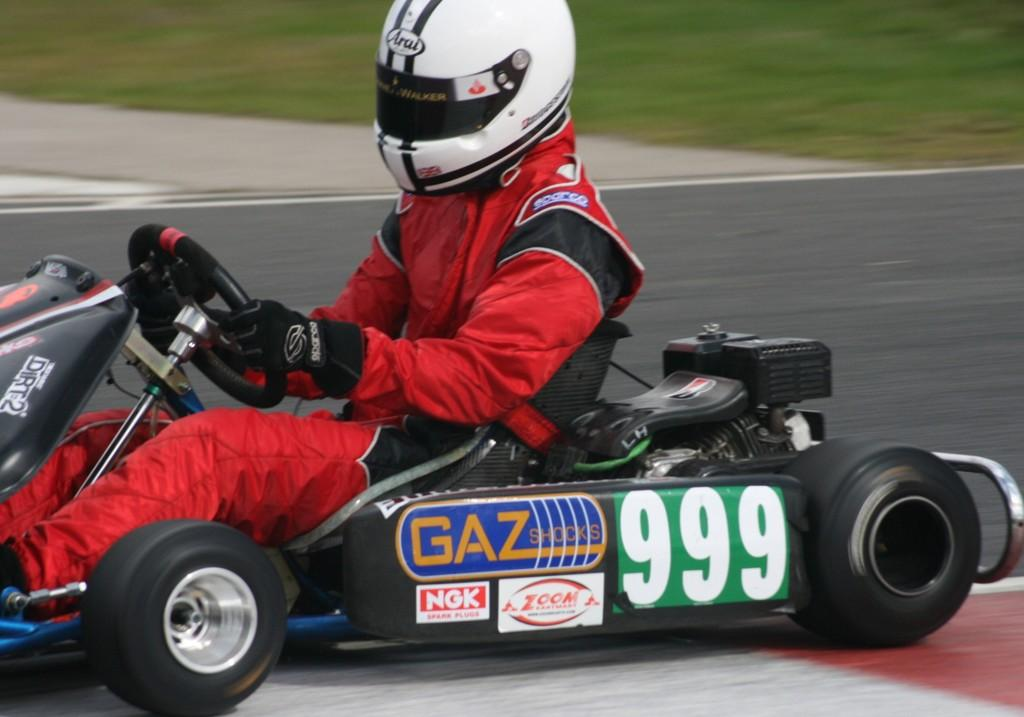What activity is the person in the image engaged in? The person in the image is doing go karting. Where is the go karting taking place? The go karting is taking place on a road. What can be seen in the background of the image? There is grass visible in the background of the image. What type of hammer is being used by the person in the image? There is no hammer present in the image; the person is doing go karting. What is the end result of the go karting activity in the image? The image does not show the end result of the go karting activity, as it is a still image. 